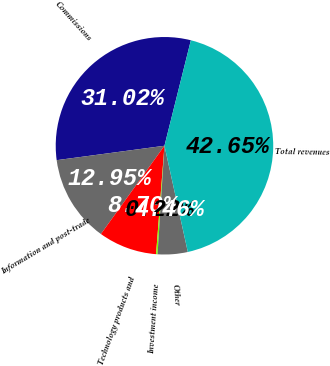<chart> <loc_0><loc_0><loc_500><loc_500><pie_chart><fcel>Commissions<fcel>Information and post-trade<fcel>Technology products and<fcel>Investment income<fcel>Other<fcel>Total revenues<nl><fcel>31.02%<fcel>12.95%<fcel>8.7%<fcel>0.22%<fcel>4.46%<fcel>42.65%<nl></chart> 